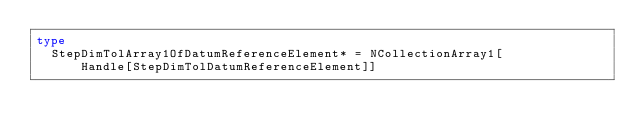<code> <loc_0><loc_0><loc_500><loc_500><_Nim_>type
  StepDimTolArray1OfDatumReferenceElement* = NCollectionArray1[
      Handle[StepDimTolDatumReferenceElement]]
</code> 